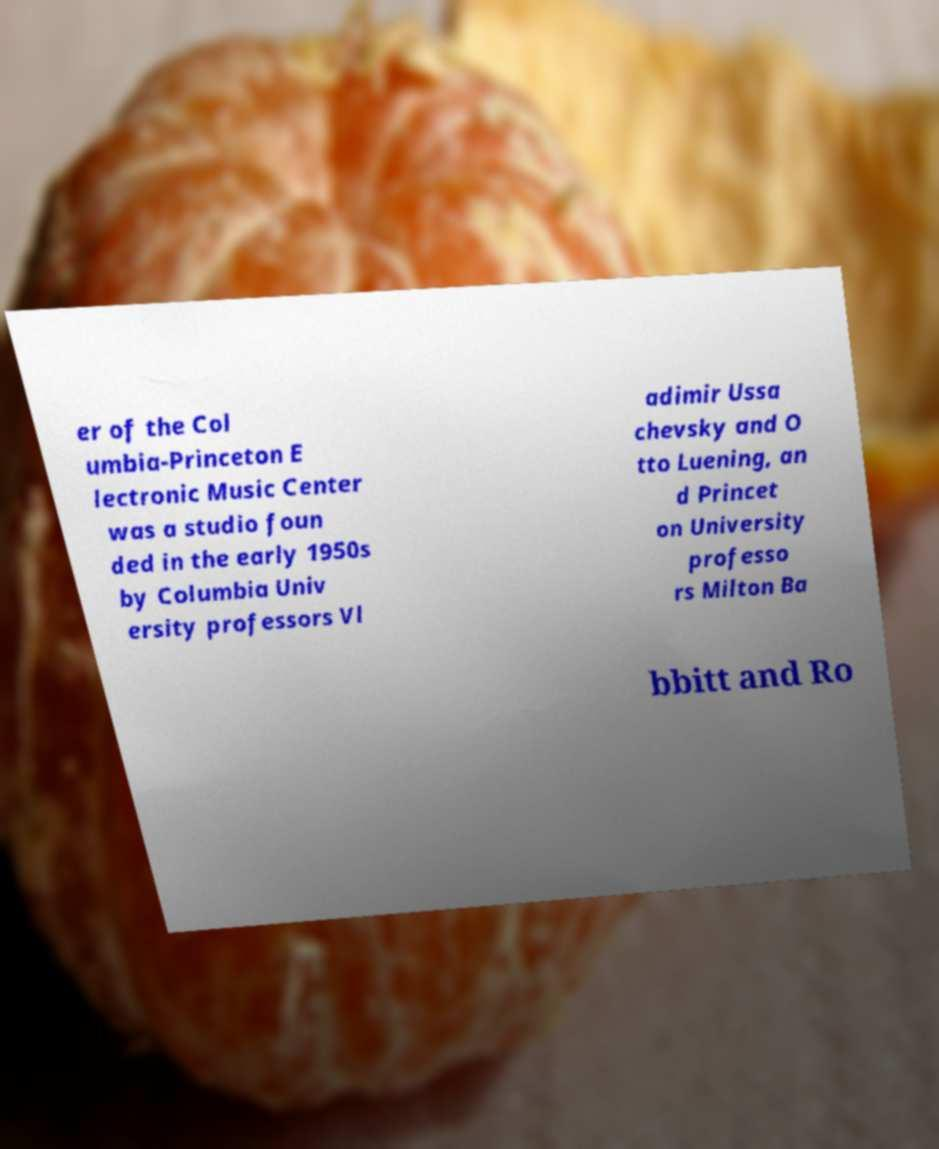I need the written content from this picture converted into text. Can you do that? er of the Col umbia-Princeton E lectronic Music Center was a studio foun ded in the early 1950s by Columbia Univ ersity professors Vl adimir Ussa chevsky and O tto Luening, an d Princet on University professo rs Milton Ba bbitt and Ro 